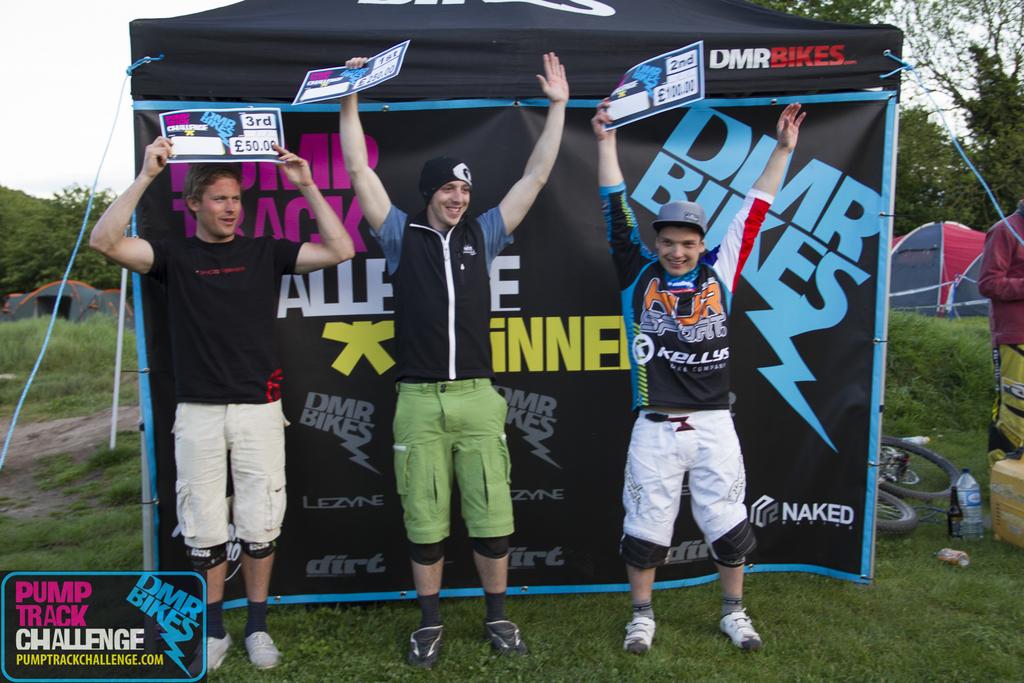What's the first player 's running tag?
Your response must be concise. Unanswerable. What is the name of this challenge?
Your answer should be compact. Pump track challenge. 